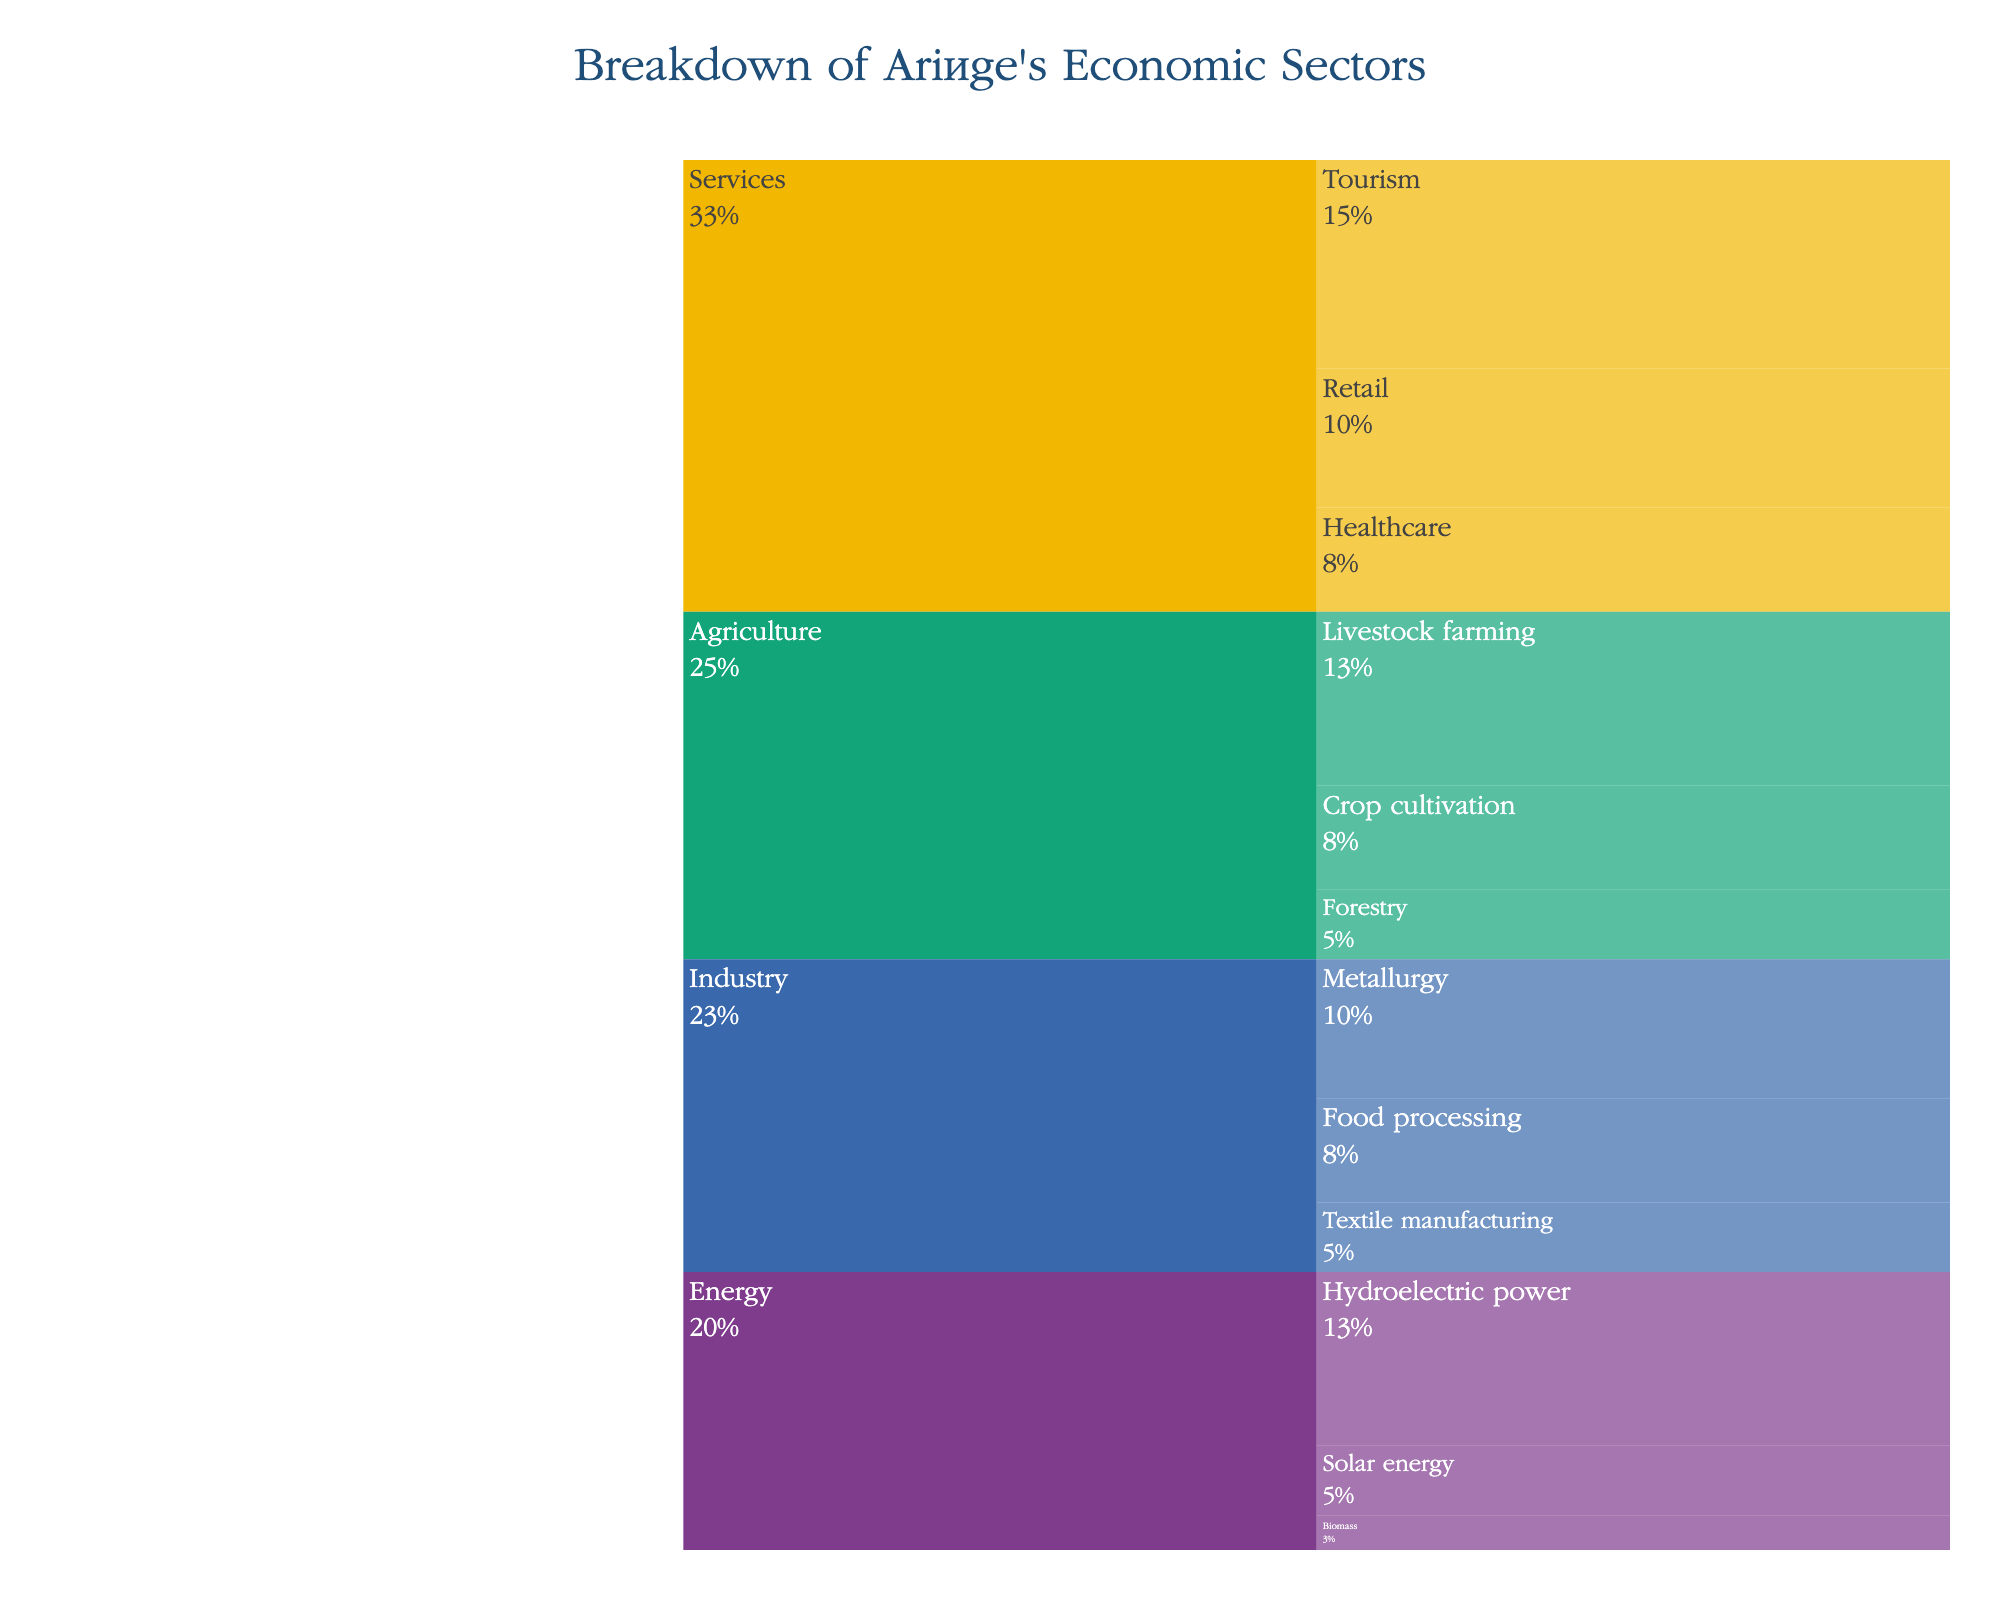What is the title of the chart? The title is prominently displayed at the top of the chart and reads: "Breakdown of Ariège's Economic Sectors".
Answer: Breakdown of Ariège's Economic Sectors Which sector has the highest contribution and what is its value? The sector with the highest contribution is "Services" with a total value of 65 (30 for Tourism, 20 for Retail, and 15 for Healthcare).
Answer: Services, 65 What is the percentage contribution of Livestock farming within the Agriculture sector? The Agriculture sector has a total value of 50 (25+15+10). The contribution of Livestock farming is 25, so the percentage is (25/50) * 100%.
Answer: 50% Comparing the subsectors of Industry, which one has the lowest value and what is it? The subsectors of Industry are Metallurgy (20), Food processing (15), and Textile manufacturing (10). The lowest value is Textile manufacturing with 10.
Answer: Textile manufacturing, 10 Which sector(s) have a subsector that has a value of 25? Reviewing the sectors, Agriculture has Livestock farming at 25, and Energy has Hydroelectric power at 25.
Answer: Agriculture and Energy What is the combined value of the non-renewable energy subsectors? In Energy, the non-renewable energies are not specified, assuming Hydro, Solar, and Biomass are renewable. So combined value assuming all are renewable is Hydro (25) + Solar (10) + Biomass (5) = 40. There are no non-renewable energy subsectors specified.
Answer: 0 Which subsector has the highest value in the Services sector? In the Services sector, the subsectors are Tourism (30), Retail (20), and Healthcare (15). Tourism has the highest value of 30.
Answer: Tourism How does Agriculture's total value compare to Energy's total value? Agriculture's total value is 50 (25+15+10) and Energy's total value is 40 (25+10+5). Therefore, Agriculture has a higher total value compared to Energy by a difference of 10.
Answer: Agriculture is higher by 10 What is the total contribution value of all sectors combined? Summing up all sectors: Agriculture (50), Industry (45), Services (65), and Energy (40). The total is 50+45+65+40 = 200.
Answer: 200 